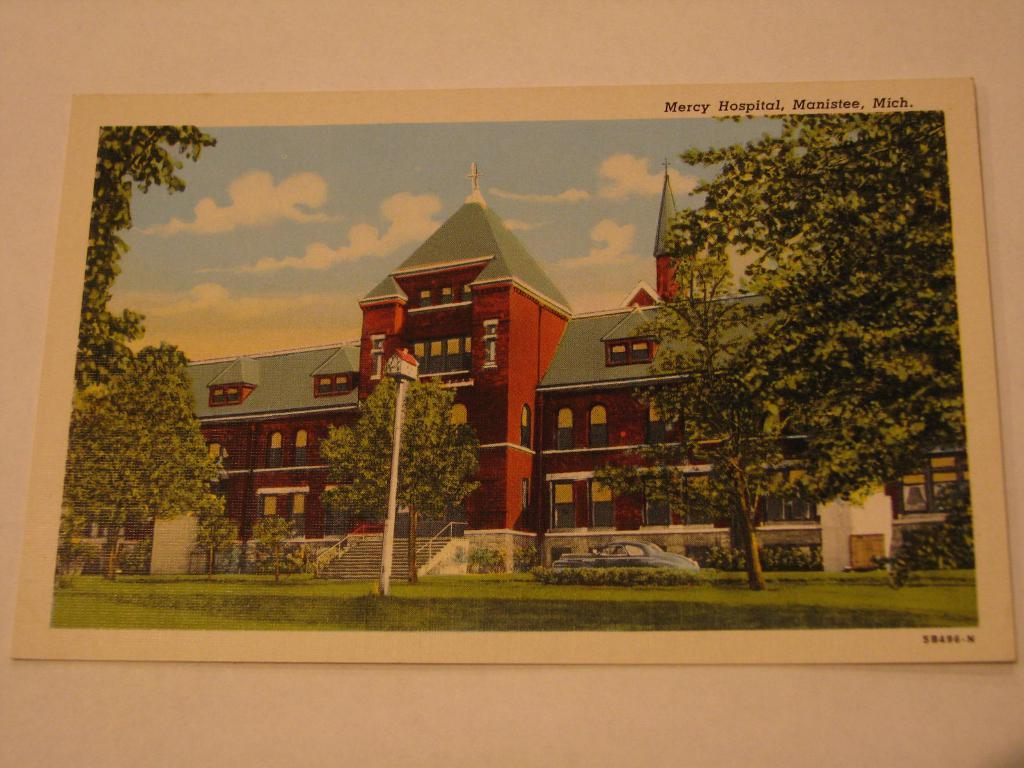What is the main object in the image? The image contains a card. Where is the card located in the image? The card is pasted on a wall. What is depicted on the card? There is a building depicted on the card, along with sky and trees. How many mice are running across the card in the image? There are no mice depicted on the card; it features a building, sky, and trees. 